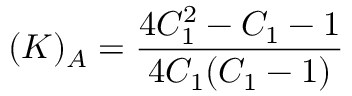Convert formula to latex. <formula><loc_0><loc_0><loc_500><loc_500>( K ) _ { A } = \frac { 4 C _ { 1 } ^ { 2 } - C _ { 1 } - 1 } { 4 C _ { 1 } ( C _ { 1 } - 1 ) }</formula> 